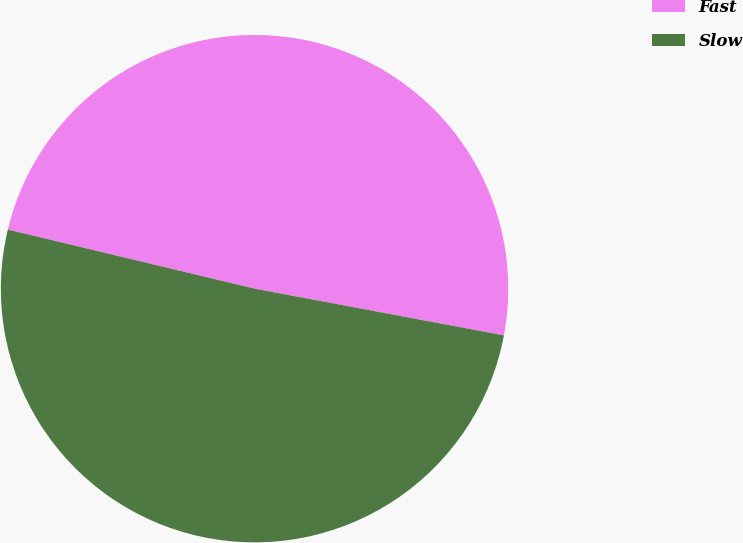Convert chart. <chart><loc_0><loc_0><loc_500><loc_500><pie_chart><fcel>Fast<fcel>Slow<nl><fcel>49.21%<fcel>50.79%<nl></chart> 